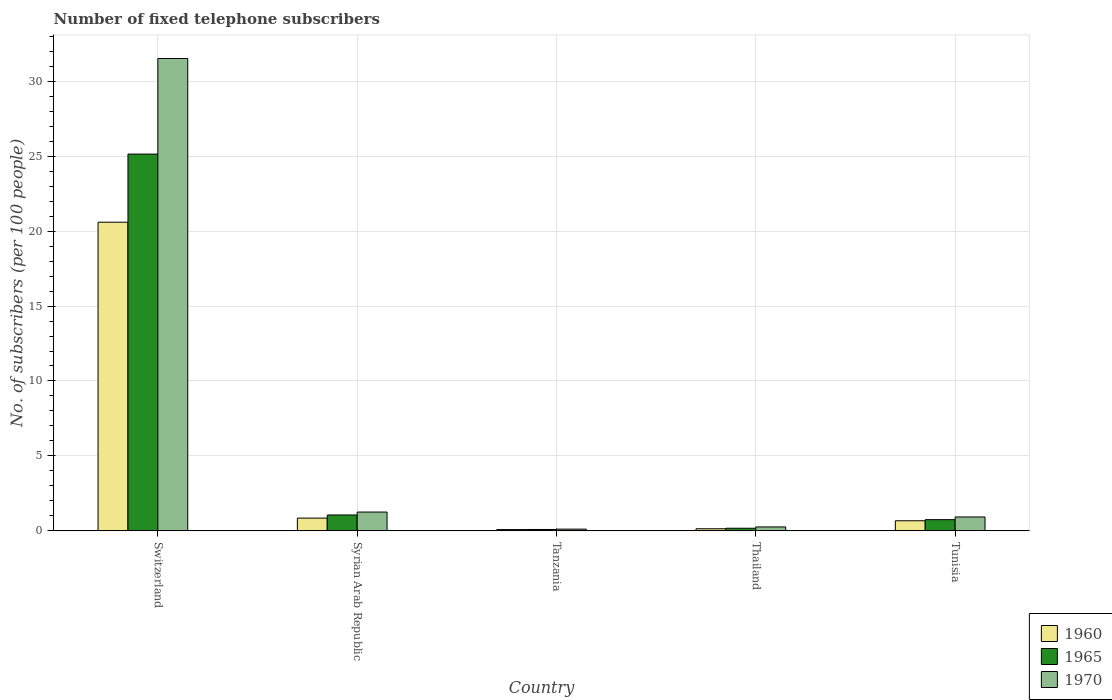How many different coloured bars are there?
Offer a terse response. 3. How many groups of bars are there?
Make the answer very short. 5. Are the number of bars on each tick of the X-axis equal?
Provide a short and direct response. Yes. How many bars are there on the 5th tick from the left?
Make the answer very short. 3. What is the label of the 3rd group of bars from the left?
Give a very brief answer. Tanzania. What is the number of fixed telephone subscribers in 1970 in Switzerland?
Your answer should be compact. 31.53. Across all countries, what is the maximum number of fixed telephone subscribers in 1960?
Provide a succinct answer. 20.6. Across all countries, what is the minimum number of fixed telephone subscribers in 1960?
Keep it short and to the point. 0.08. In which country was the number of fixed telephone subscribers in 1960 maximum?
Offer a very short reply. Switzerland. In which country was the number of fixed telephone subscribers in 1970 minimum?
Your answer should be very brief. Tanzania. What is the total number of fixed telephone subscribers in 1960 in the graph?
Keep it short and to the point. 22.33. What is the difference between the number of fixed telephone subscribers in 1965 in Tanzania and that in Thailand?
Offer a very short reply. -0.08. What is the difference between the number of fixed telephone subscribers in 1960 in Thailand and the number of fixed telephone subscribers in 1965 in Syrian Arab Republic?
Give a very brief answer. -0.92. What is the average number of fixed telephone subscribers in 1970 per country?
Give a very brief answer. 6.81. What is the difference between the number of fixed telephone subscribers of/in 1960 and number of fixed telephone subscribers of/in 1965 in Switzerland?
Offer a terse response. -4.55. In how many countries, is the number of fixed telephone subscribers in 1960 greater than 12?
Offer a very short reply. 1. What is the ratio of the number of fixed telephone subscribers in 1960 in Switzerland to that in Thailand?
Provide a short and direct response. 151.73. Is the difference between the number of fixed telephone subscribers in 1960 in Switzerland and Tanzania greater than the difference between the number of fixed telephone subscribers in 1965 in Switzerland and Tanzania?
Make the answer very short. No. What is the difference between the highest and the second highest number of fixed telephone subscribers in 1965?
Your response must be concise. -24.4. What is the difference between the highest and the lowest number of fixed telephone subscribers in 1965?
Offer a very short reply. 25.06. What does the 1st bar from the left in Tanzania represents?
Make the answer very short. 1960. What does the 2nd bar from the right in Tunisia represents?
Your answer should be very brief. 1965. Is it the case that in every country, the sum of the number of fixed telephone subscribers in 1970 and number of fixed telephone subscribers in 1965 is greater than the number of fixed telephone subscribers in 1960?
Keep it short and to the point. Yes. How many bars are there?
Provide a succinct answer. 15. Are the values on the major ticks of Y-axis written in scientific E-notation?
Keep it short and to the point. No. Does the graph contain any zero values?
Offer a very short reply. No. Where does the legend appear in the graph?
Ensure brevity in your answer.  Bottom right. How are the legend labels stacked?
Offer a very short reply. Vertical. What is the title of the graph?
Keep it short and to the point. Number of fixed telephone subscribers. Does "1981" appear as one of the legend labels in the graph?
Keep it short and to the point. No. What is the label or title of the X-axis?
Make the answer very short. Country. What is the label or title of the Y-axis?
Offer a very short reply. No. of subscribers (per 100 people). What is the No. of subscribers (per 100 people) of 1960 in Switzerland?
Provide a short and direct response. 20.6. What is the No. of subscribers (per 100 people) of 1965 in Switzerland?
Offer a terse response. 25.15. What is the No. of subscribers (per 100 people) of 1970 in Switzerland?
Your response must be concise. 31.53. What is the No. of subscribers (per 100 people) in 1960 in Syrian Arab Republic?
Give a very brief answer. 0.85. What is the No. of subscribers (per 100 people) of 1965 in Syrian Arab Republic?
Your response must be concise. 1.06. What is the No. of subscribers (per 100 people) of 1970 in Syrian Arab Republic?
Make the answer very short. 1.25. What is the No. of subscribers (per 100 people) in 1960 in Tanzania?
Keep it short and to the point. 0.08. What is the No. of subscribers (per 100 people) of 1965 in Tanzania?
Make the answer very short. 0.09. What is the No. of subscribers (per 100 people) in 1970 in Tanzania?
Offer a terse response. 0.11. What is the No. of subscribers (per 100 people) in 1960 in Thailand?
Your response must be concise. 0.14. What is the No. of subscribers (per 100 people) in 1965 in Thailand?
Give a very brief answer. 0.17. What is the No. of subscribers (per 100 people) of 1970 in Thailand?
Your answer should be compact. 0.26. What is the No. of subscribers (per 100 people) in 1960 in Tunisia?
Provide a short and direct response. 0.67. What is the No. of subscribers (per 100 people) in 1965 in Tunisia?
Provide a short and direct response. 0.74. What is the No. of subscribers (per 100 people) in 1970 in Tunisia?
Your response must be concise. 0.92. Across all countries, what is the maximum No. of subscribers (per 100 people) in 1960?
Make the answer very short. 20.6. Across all countries, what is the maximum No. of subscribers (per 100 people) of 1965?
Your answer should be very brief. 25.15. Across all countries, what is the maximum No. of subscribers (per 100 people) of 1970?
Offer a very short reply. 31.53. Across all countries, what is the minimum No. of subscribers (per 100 people) in 1960?
Provide a succinct answer. 0.08. Across all countries, what is the minimum No. of subscribers (per 100 people) of 1965?
Offer a terse response. 0.09. Across all countries, what is the minimum No. of subscribers (per 100 people) in 1970?
Offer a very short reply. 0.11. What is the total No. of subscribers (per 100 people) in 1960 in the graph?
Your answer should be very brief. 22.33. What is the total No. of subscribers (per 100 people) of 1965 in the graph?
Make the answer very short. 27.2. What is the total No. of subscribers (per 100 people) in 1970 in the graph?
Your answer should be very brief. 34.07. What is the difference between the No. of subscribers (per 100 people) of 1960 in Switzerland and that in Syrian Arab Republic?
Your response must be concise. 19.75. What is the difference between the No. of subscribers (per 100 people) of 1965 in Switzerland and that in Syrian Arab Republic?
Give a very brief answer. 24.09. What is the difference between the No. of subscribers (per 100 people) in 1970 in Switzerland and that in Syrian Arab Republic?
Provide a short and direct response. 30.28. What is the difference between the No. of subscribers (per 100 people) of 1960 in Switzerland and that in Tanzania?
Your answer should be compact. 20.52. What is the difference between the No. of subscribers (per 100 people) of 1965 in Switzerland and that in Tanzania?
Offer a very short reply. 25.06. What is the difference between the No. of subscribers (per 100 people) in 1970 in Switzerland and that in Tanzania?
Provide a short and direct response. 31.42. What is the difference between the No. of subscribers (per 100 people) of 1960 in Switzerland and that in Thailand?
Your response must be concise. 20.46. What is the difference between the No. of subscribers (per 100 people) in 1965 in Switzerland and that in Thailand?
Offer a very short reply. 24.98. What is the difference between the No. of subscribers (per 100 people) in 1970 in Switzerland and that in Thailand?
Your answer should be compact. 31.27. What is the difference between the No. of subscribers (per 100 people) of 1960 in Switzerland and that in Tunisia?
Keep it short and to the point. 19.93. What is the difference between the No. of subscribers (per 100 people) of 1965 in Switzerland and that in Tunisia?
Make the answer very short. 24.4. What is the difference between the No. of subscribers (per 100 people) in 1970 in Switzerland and that in Tunisia?
Provide a succinct answer. 30.6. What is the difference between the No. of subscribers (per 100 people) in 1960 in Syrian Arab Republic and that in Tanzania?
Your response must be concise. 0.77. What is the difference between the No. of subscribers (per 100 people) in 1965 in Syrian Arab Republic and that in Tanzania?
Provide a short and direct response. 0.97. What is the difference between the No. of subscribers (per 100 people) of 1970 in Syrian Arab Republic and that in Tanzania?
Make the answer very short. 1.14. What is the difference between the No. of subscribers (per 100 people) of 1960 in Syrian Arab Republic and that in Thailand?
Make the answer very short. 0.71. What is the difference between the No. of subscribers (per 100 people) in 1965 in Syrian Arab Republic and that in Thailand?
Your answer should be compact. 0.89. What is the difference between the No. of subscribers (per 100 people) in 1960 in Syrian Arab Republic and that in Tunisia?
Give a very brief answer. 0.18. What is the difference between the No. of subscribers (per 100 people) in 1965 in Syrian Arab Republic and that in Tunisia?
Keep it short and to the point. 0.31. What is the difference between the No. of subscribers (per 100 people) of 1970 in Syrian Arab Republic and that in Tunisia?
Provide a succinct answer. 0.33. What is the difference between the No. of subscribers (per 100 people) of 1960 in Tanzania and that in Thailand?
Ensure brevity in your answer.  -0.06. What is the difference between the No. of subscribers (per 100 people) of 1965 in Tanzania and that in Thailand?
Provide a short and direct response. -0.08. What is the difference between the No. of subscribers (per 100 people) of 1970 in Tanzania and that in Thailand?
Provide a short and direct response. -0.15. What is the difference between the No. of subscribers (per 100 people) of 1960 in Tanzania and that in Tunisia?
Provide a succinct answer. -0.59. What is the difference between the No. of subscribers (per 100 people) in 1965 in Tanzania and that in Tunisia?
Offer a terse response. -0.66. What is the difference between the No. of subscribers (per 100 people) of 1970 in Tanzania and that in Tunisia?
Provide a succinct answer. -0.81. What is the difference between the No. of subscribers (per 100 people) in 1960 in Thailand and that in Tunisia?
Keep it short and to the point. -0.53. What is the difference between the No. of subscribers (per 100 people) of 1965 in Thailand and that in Tunisia?
Make the answer very short. -0.57. What is the difference between the No. of subscribers (per 100 people) in 1970 in Thailand and that in Tunisia?
Ensure brevity in your answer.  -0.67. What is the difference between the No. of subscribers (per 100 people) of 1960 in Switzerland and the No. of subscribers (per 100 people) of 1965 in Syrian Arab Republic?
Offer a terse response. 19.54. What is the difference between the No. of subscribers (per 100 people) of 1960 in Switzerland and the No. of subscribers (per 100 people) of 1970 in Syrian Arab Republic?
Ensure brevity in your answer.  19.35. What is the difference between the No. of subscribers (per 100 people) in 1965 in Switzerland and the No. of subscribers (per 100 people) in 1970 in Syrian Arab Republic?
Ensure brevity in your answer.  23.9. What is the difference between the No. of subscribers (per 100 people) of 1960 in Switzerland and the No. of subscribers (per 100 people) of 1965 in Tanzania?
Ensure brevity in your answer.  20.51. What is the difference between the No. of subscribers (per 100 people) in 1960 in Switzerland and the No. of subscribers (per 100 people) in 1970 in Tanzania?
Your response must be concise. 20.49. What is the difference between the No. of subscribers (per 100 people) of 1965 in Switzerland and the No. of subscribers (per 100 people) of 1970 in Tanzania?
Provide a short and direct response. 25.04. What is the difference between the No. of subscribers (per 100 people) in 1960 in Switzerland and the No. of subscribers (per 100 people) in 1965 in Thailand?
Provide a succinct answer. 20.43. What is the difference between the No. of subscribers (per 100 people) in 1960 in Switzerland and the No. of subscribers (per 100 people) in 1970 in Thailand?
Make the answer very short. 20.34. What is the difference between the No. of subscribers (per 100 people) of 1965 in Switzerland and the No. of subscribers (per 100 people) of 1970 in Thailand?
Your response must be concise. 24.89. What is the difference between the No. of subscribers (per 100 people) of 1960 in Switzerland and the No. of subscribers (per 100 people) of 1965 in Tunisia?
Give a very brief answer. 19.86. What is the difference between the No. of subscribers (per 100 people) of 1960 in Switzerland and the No. of subscribers (per 100 people) of 1970 in Tunisia?
Your response must be concise. 19.68. What is the difference between the No. of subscribers (per 100 people) of 1965 in Switzerland and the No. of subscribers (per 100 people) of 1970 in Tunisia?
Provide a succinct answer. 24.22. What is the difference between the No. of subscribers (per 100 people) in 1960 in Syrian Arab Republic and the No. of subscribers (per 100 people) in 1965 in Tanzania?
Your response must be concise. 0.76. What is the difference between the No. of subscribers (per 100 people) in 1960 in Syrian Arab Republic and the No. of subscribers (per 100 people) in 1970 in Tanzania?
Give a very brief answer. 0.74. What is the difference between the No. of subscribers (per 100 people) of 1965 in Syrian Arab Republic and the No. of subscribers (per 100 people) of 1970 in Tanzania?
Your answer should be very brief. 0.95. What is the difference between the No. of subscribers (per 100 people) in 1960 in Syrian Arab Republic and the No. of subscribers (per 100 people) in 1965 in Thailand?
Provide a short and direct response. 0.68. What is the difference between the No. of subscribers (per 100 people) in 1960 in Syrian Arab Republic and the No. of subscribers (per 100 people) in 1970 in Thailand?
Offer a terse response. 0.59. What is the difference between the No. of subscribers (per 100 people) in 1965 in Syrian Arab Republic and the No. of subscribers (per 100 people) in 1970 in Thailand?
Your answer should be compact. 0.8. What is the difference between the No. of subscribers (per 100 people) in 1960 in Syrian Arab Republic and the No. of subscribers (per 100 people) in 1965 in Tunisia?
Ensure brevity in your answer.  0.1. What is the difference between the No. of subscribers (per 100 people) of 1960 in Syrian Arab Republic and the No. of subscribers (per 100 people) of 1970 in Tunisia?
Make the answer very short. -0.08. What is the difference between the No. of subscribers (per 100 people) of 1965 in Syrian Arab Republic and the No. of subscribers (per 100 people) of 1970 in Tunisia?
Make the answer very short. 0.13. What is the difference between the No. of subscribers (per 100 people) in 1960 in Tanzania and the No. of subscribers (per 100 people) in 1965 in Thailand?
Your answer should be very brief. -0.09. What is the difference between the No. of subscribers (per 100 people) of 1960 in Tanzania and the No. of subscribers (per 100 people) of 1970 in Thailand?
Your response must be concise. -0.18. What is the difference between the No. of subscribers (per 100 people) of 1965 in Tanzania and the No. of subscribers (per 100 people) of 1970 in Thailand?
Provide a short and direct response. -0.17. What is the difference between the No. of subscribers (per 100 people) in 1960 in Tanzania and the No. of subscribers (per 100 people) in 1965 in Tunisia?
Your answer should be compact. -0.66. What is the difference between the No. of subscribers (per 100 people) of 1960 in Tanzania and the No. of subscribers (per 100 people) of 1970 in Tunisia?
Offer a very short reply. -0.84. What is the difference between the No. of subscribers (per 100 people) in 1965 in Tanzania and the No. of subscribers (per 100 people) in 1970 in Tunisia?
Your response must be concise. -0.84. What is the difference between the No. of subscribers (per 100 people) in 1960 in Thailand and the No. of subscribers (per 100 people) in 1965 in Tunisia?
Give a very brief answer. -0.61. What is the difference between the No. of subscribers (per 100 people) of 1960 in Thailand and the No. of subscribers (per 100 people) of 1970 in Tunisia?
Make the answer very short. -0.79. What is the difference between the No. of subscribers (per 100 people) of 1965 in Thailand and the No. of subscribers (per 100 people) of 1970 in Tunisia?
Offer a terse response. -0.75. What is the average No. of subscribers (per 100 people) of 1960 per country?
Keep it short and to the point. 4.47. What is the average No. of subscribers (per 100 people) in 1965 per country?
Keep it short and to the point. 5.44. What is the average No. of subscribers (per 100 people) in 1970 per country?
Give a very brief answer. 6.81. What is the difference between the No. of subscribers (per 100 people) of 1960 and No. of subscribers (per 100 people) of 1965 in Switzerland?
Make the answer very short. -4.55. What is the difference between the No. of subscribers (per 100 people) of 1960 and No. of subscribers (per 100 people) of 1970 in Switzerland?
Provide a succinct answer. -10.93. What is the difference between the No. of subscribers (per 100 people) in 1965 and No. of subscribers (per 100 people) in 1970 in Switzerland?
Make the answer very short. -6.38. What is the difference between the No. of subscribers (per 100 people) in 1960 and No. of subscribers (per 100 people) in 1965 in Syrian Arab Republic?
Your answer should be compact. -0.21. What is the difference between the No. of subscribers (per 100 people) of 1960 and No. of subscribers (per 100 people) of 1970 in Syrian Arab Republic?
Your response must be concise. -0.4. What is the difference between the No. of subscribers (per 100 people) of 1965 and No. of subscribers (per 100 people) of 1970 in Syrian Arab Republic?
Provide a succinct answer. -0.2. What is the difference between the No. of subscribers (per 100 people) in 1960 and No. of subscribers (per 100 people) in 1965 in Tanzania?
Provide a short and direct response. -0.01. What is the difference between the No. of subscribers (per 100 people) of 1960 and No. of subscribers (per 100 people) of 1970 in Tanzania?
Give a very brief answer. -0.03. What is the difference between the No. of subscribers (per 100 people) of 1965 and No. of subscribers (per 100 people) of 1970 in Tanzania?
Keep it short and to the point. -0.02. What is the difference between the No. of subscribers (per 100 people) of 1960 and No. of subscribers (per 100 people) of 1965 in Thailand?
Offer a terse response. -0.03. What is the difference between the No. of subscribers (per 100 people) of 1960 and No. of subscribers (per 100 people) of 1970 in Thailand?
Provide a short and direct response. -0.12. What is the difference between the No. of subscribers (per 100 people) in 1965 and No. of subscribers (per 100 people) in 1970 in Thailand?
Give a very brief answer. -0.09. What is the difference between the No. of subscribers (per 100 people) in 1960 and No. of subscribers (per 100 people) in 1965 in Tunisia?
Your answer should be compact. -0.07. What is the difference between the No. of subscribers (per 100 people) of 1960 and No. of subscribers (per 100 people) of 1970 in Tunisia?
Make the answer very short. -0.25. What is the difference between the No. of subscribers (per 100 people) of 1965 and No. of subscribers (per 100 people) of 1970 in Tunisia?
Your response must be concise. -0.18. What is the ratio of the No. of subscribers (per 100 people) of 1960 in Switzerland to that in Syrian Arab Republic?
Offer a very short reply. 24.33. What is the ratio of the No. of subscribers (per 100 people) of 1965 in Switzerland to that in Syrian Arab Republic?
Give a very brief answer. 23.82. What is the ratio of the No. of subscribers (per 100 people) of 1970 in Switzerland to that in Syrian Arab Republic?
Your answer should be very brief. 25.2. What is the ratio of the No. of subscribers (per 100 people) of 1960 in Switzerland to that in Tanzania?
Ensure brevity in your answer.  255.26. What is the ratio of the No. of subscribers (per 100 people) in 1965 in Switzerland to that in Tanzania?
Your answer should be compact. 287.14. What is the ratio of the No. of subscribers (per 100 people) in 1970 in Switzerland to that in Tanzania?
Offer a very short reply. 286.38. What is the ratio of the No. of subscribers (per 100 people) of 1960 in Switzerland to that in Thailand?
Ensure brevity in your answer.  151.73. What is the ratio of the No. of subscribers (per 100 people) of 1965 in Switzerland to that in Thailand?
Give a very brief answer. 148.16. What is the ratio of the No. of subscribers (per 100 people) of 1970 in Switzerland to that in Thailand?
Ensure brevity in your answer.  122.39. What is the ratio of the No. of subscribers (per 100 people) of 1960 in Switzerland to that in Tunisia?
Your answer should be very brief. 30.76. What is the ratio of the No. of subscribers (per 100 people) of 1965 in Switzerland to that in Tunisia?
Offer a very short reply. 33.82. What is the ratio of the No. of subscribers (per 100 people) of 1970 in Switzerland to that in Tunisia?
Keep it short and to the point. 34.15. What is the ratio of the No. of subscribers (per 100 people) of 1960 in Syrian Arab Republic to that in Tanzania?
Your answer should be very brief. 10.49. What is the ratio of the No. of subscribers (per 100 people) of 1965 in Syrian Arab Republic to that in Tanzania?
Offer a very short reply. 12.06. What is the ratio of the No. of subscribers (per 100 people) in 1970 in Syrian Arab Republic to that in Tanzania?
Give a very brief answer. 11.36. What is the ratio of the No. of subscribers (per 100 people) in 1960 in Syrian Arab Republic to that in Thailand?
Give a very brief answer. 6.24. What is the ratio of the No. of subscribers (per 100 people) of 1965 in Syrian Arab Republic to that in Thailand?
Keep it short and to the point. 6.22. What is the ratio of the No. of subscribers (per 100 people) in 1970 in Syrian Arab Republic to that in Thailand?
Offer a terse response. 4.86. What is the ratio of the No. of subscribers (per 100 people) in 1960 in Syrian Arab Republic to that in Tunisia?
Your answer should be very brief. 1.26. What is the ratio of the No. of subscribers (per 100 people) in 1965 in Syrian Arab Republic to that in Tunisia?
Provide a short and direct response. 1.42. What is the ratio of the No. of subscribers (per 100 people) of 1970 in Syrian Arab Republic to that in Tunisia?
Your answer should be compact. 1.35. What is the ratio of the No. of subscribers (per 100 people) in 1960 in Tanzania to that in Thailand?
Provide a succinct answer. 0.59. What is the ratio of the No. of subscribers (per 100 people) of 1965 in Tanzania to that in Thailand?
Make the answer very short. 0.52. What is the ratio of the No. of subscribers (per 100 people) in 1970 in Tanzania to that in Thailand?
Make the answer very short. 0.43. What is the ratio of the No. of subscribers (per 100 people) of 1960 in Tanzania to that in Tunisia?
Ensure brevity in your answer.  0.12. What is the ratio of the No. of subscribers (per 100 people) in 1965 in Tanzania to that in Tunisia?
Offer a terse response. 0.12. What is the ratio of the No. of subscribers (per 100 people) in 1970 in Tanzania to that in Tunisia?
Your response must be concise. 0.12. What is the ratio of the No. of subscribers (per 100 people) in 1960 in Thailand to that in Tunisia?
Your answer should be very brief. 0.2. What is the ratio of the No. of subscribers (per 100 people) of 1965 in Thailand to that in Tunisia?
Your answer should be compact. 0.23. What is the ratio of the No. of subscribers (per 100 people) in 1970 in Thailand to that in Tunisia?
Make the answer very short. 0.28. What is the difference between the highest and the second highest No. of subscribers (per 100 people) of 1960?
Make the answer very short. 19.75. What is the difference between the highest and the second highest No. of subscribers (per 100 people) in 1965?
Provide a short and direct response. 24.09. What is the difference between the highest and the second highest No. of subscribers (per 100 people) of 1970?
Offer a very short reply. 30.28. What is the difference between the highest and the lowest No. of subscribers (per 100 people) of 1960?
Offer a terse response. 20.52. What is the difference between the highest and the lowest No. of subscribers (per 100 people) of 1965?
Your answer should be very brief. 25.06. What is the difference between the highest and the lowest No. of subscribers (per 100 people) in 1970?
Your response must be concise. 31.42. 